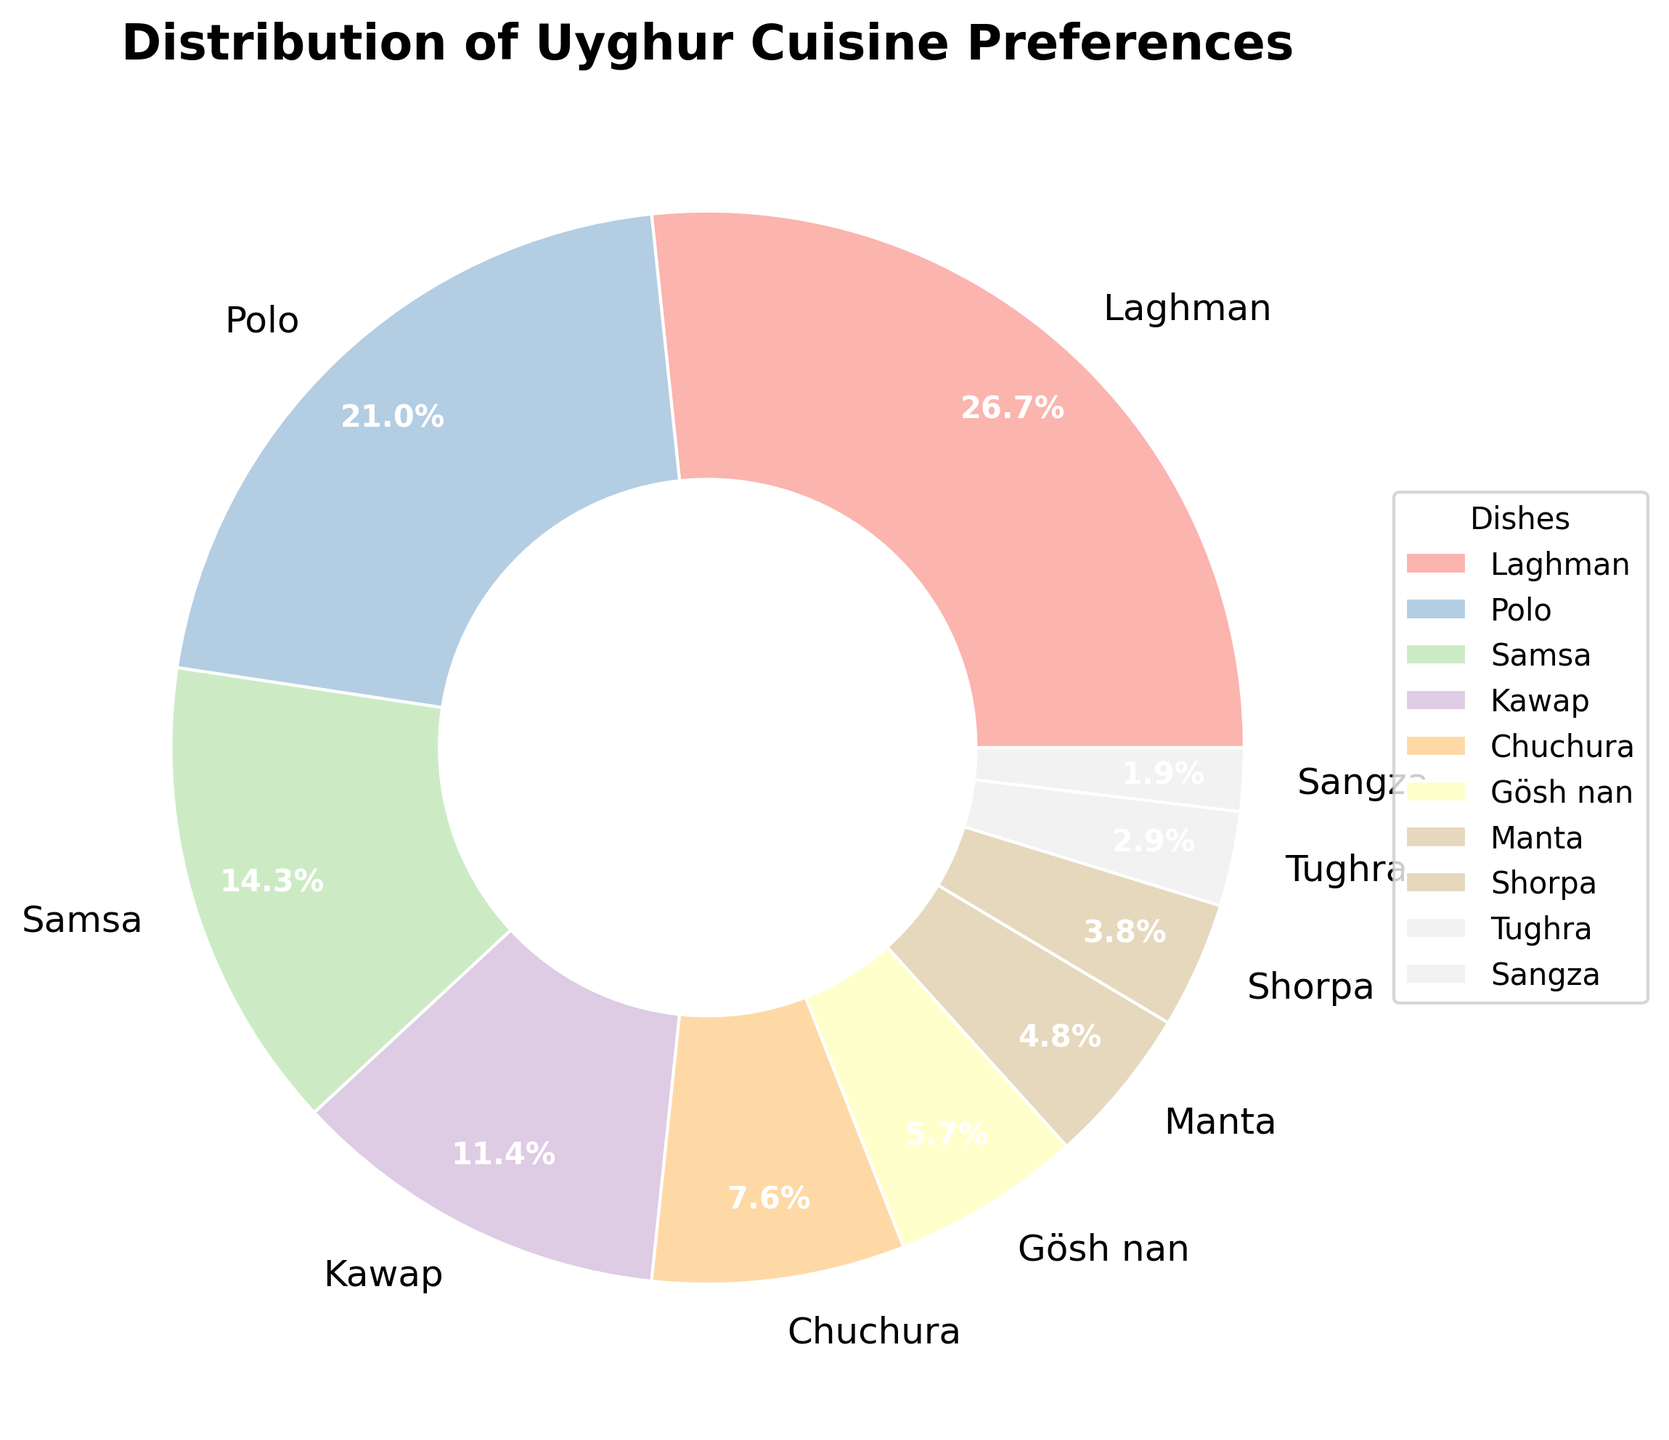What is the most preferred Uyghur dish among the students? The figure shows a pie chart with various slices representing different dishes. The largest slice corresponds to the dish "Laghman". Thus, it is the most preferred.
Answer: Laghman Which dish is the second most popular among the students? By examining the pie chart, the second largest slice represents the dish "Polo".
Answer: Polo How many dishes have a preference percentage lower than 10%? Identify and count the slices that represent less than 10%. These are "Chuchura", "Gösh nan", "Manta", "Shorpa", "Tughra", and "Sangza". There are 6 such dishes.
Answer: 6 What is the combined percentage of preferences for "Kawap" and "Samsa"? Locate the slices for "Kawap" (12%) and "Samsa" (15%) in the pie chart and add them together. 12% + 15% = 27%.
Answer: 27% How does the preference for "Sangza" compare to that for "Chuchura"? Compare the slices for "Sangza" (2%) and "Chuchura" (8%). The slice for "Sangza" is smaller, indicating it is less preferred.
Answer: Sangza is less preferred Which dish has the smallest preference? The smallest slice in the pie chart indicates the dish with the smallest preference, which is "Sangza".
Answer: Sangza How much more preferable is "Laghman" compared to "Gösh nan"? Locate both slices for "Laghman" (28%) and "Gösh nan" (6%) and subtract the smallest from the largest. 28% - 6% = 22%.
Answer: 22% What percentage of students prefer dishes other than "Kawap"? First, note the percentage of students who prefer "Kawap" which is 12%. Subtract this from 100%. 100% - 12% = 88%.
Answer: 88% How do preferences for "Gösh nan" and "Manta" visually compare? By comparing the sizes of the slices in the pie chart, the slice for "Gösh nan" (6%) is slightly larger than the one for "Manta" (5%), indicating "Gösh nan" is more preferred.
Answer: Gösh nan is more preferred What fraction of the students prefer either "Manta" or "Shorpa"? Add the percentages of "Manta" (5%) and "Shorpa" (4%), which yields 9%. The equivalent fraction is 9/100, which simplifies to 9%.
Answer: 9% 